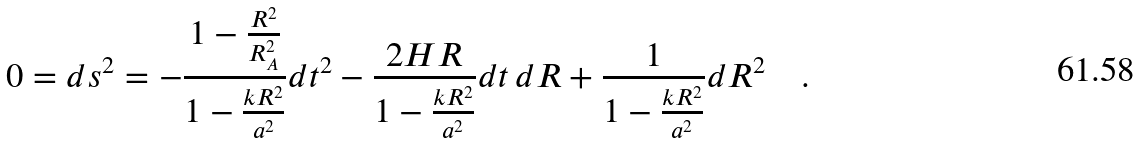<formula> <loc_0><loc_0><loc_500><loc_500>0 = d s ^ { 2 } = - \frac { 1 - \frac { R ^ { 2 } } { R _ { A } ^ { 2 } } } { 1 - \frac { k R ^ { 2 } } { a ^ { 2 } } } d t ^ { 2 } - \frac { 2 H R } { 1 - \frac { k R ^ { 2 } } { a ^ { 2 } } } d t \, d R + \frac { 1 } { 1 - \frac { k R ^ { 2 } } { a ^ { 2 } } } d R ^ { 2 } \quad .</formula> 